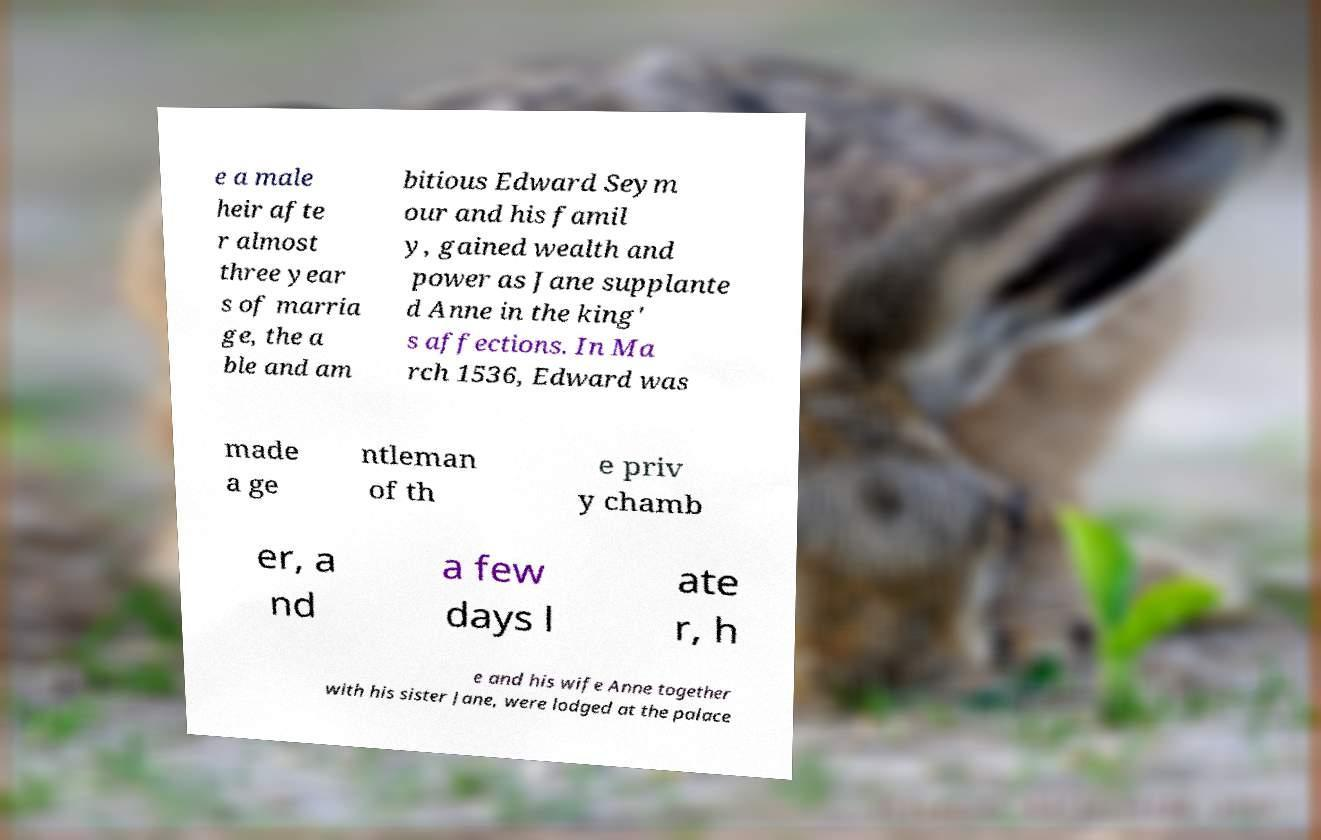I need the written content from this picture converted into text. Can you do that? e a male heir afte r almost three year s of marria ge, the a ble and am bitious Edward Seym our and his famil y, gained wealth and power as Jane supplante d Anne in the king' s affections. In Ma rch 1536, Edward was made a ge ntleman of th e priv y chamb er, a nd a few days l ate r, h e and his wife Anne together with his sister Jane, were lodged at the palace 